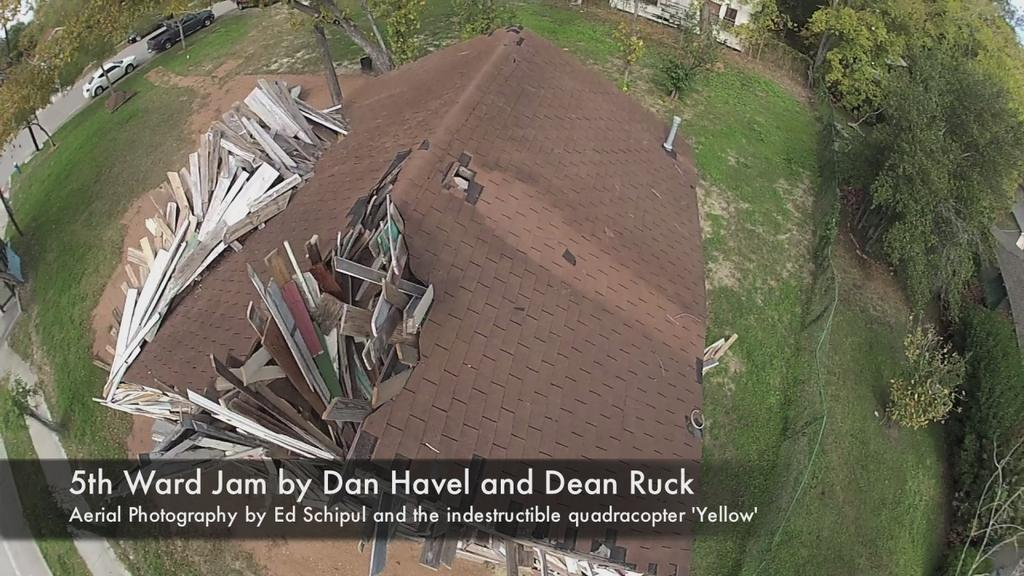What type of structure is visible in the image? There is a house with a roof in the image. What material is used for the wooden pieces in the image? The facts do not specify the material of the wooden pieces. What type of vegetation is present in the image? Grass, plants, and a group of trees are present in the image. What else can be seen on the ground in the image? There are vehicles on the ground in the image. What is visible in the sky in the image? The sky is visible in the image. How many passengers are visible in the cherry tree in the image? There are no passengers or cherry trees present in the image. 